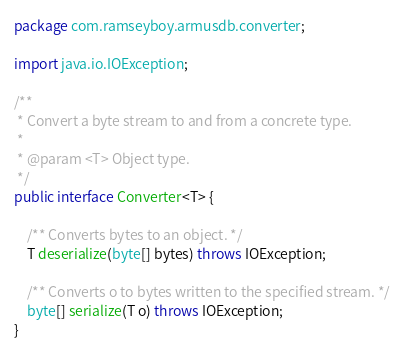Convert code to text. <code><loc_0><loc_0><loc_500><loc_500><_Java_>package com.ramseyboy.armusdb.converter;

import java.io.IOException;

/**
 * Convert a byte stream to and from a concrete type.
 *
 * @param <T> Object type.
 */
public interface Converter<T> {

    /** Converts bytes to an object. */
    T deserialize(byte[] bytes) throws IOException;

    /** Converts o to bytes written to the specified stream. */
    byte[] serialize(T o) throws IOException;
}
</code> 